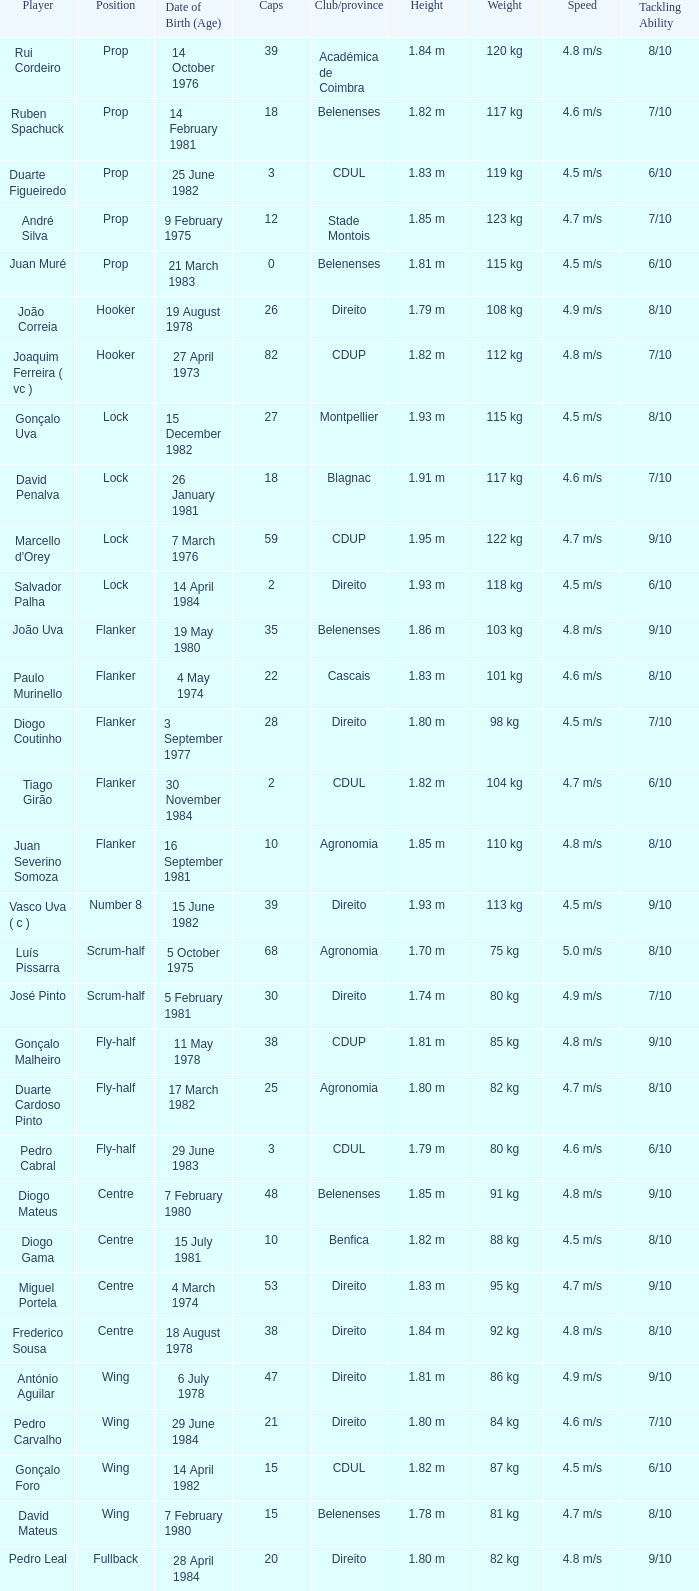How many caps have a Date of Birth (Age) of 15 july 1981? 1.0. 